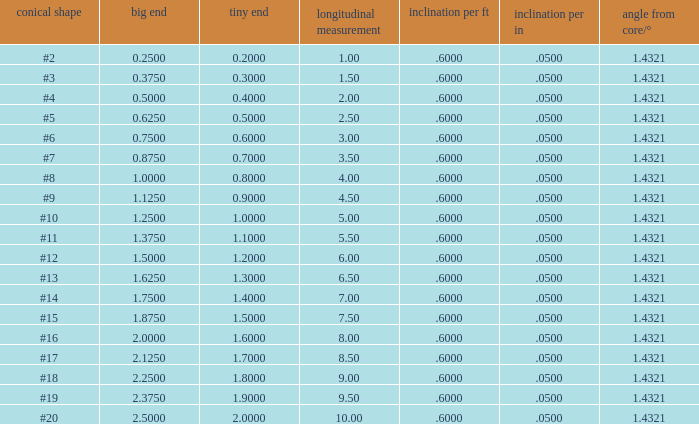Which Length has a Taper of #15, and a Large end larger than 1.875? None. Write the full table. {'header': ['conical shape', 'big end', 'tiny end', 'longitudinal measurement', 'inclination per ft', 'inclination per in', 'angle from core/°'], 'rows': [['#2', '0.2500', '0.2000', '1.00', '.6000', '.0500', '1.4321'], ['#3', '0.3750', '0.3000', '1.50', '.6000', '.0500', '1.4321'], ['#4', '0.5000', '0.4000', '2.00', '.6000', '.0500', '1.4321'], ['#5', '0.6250', '0.5000', '2.50', '.6000', '.0500', '1.4321'], ['#6', '0.7500', '0.6000', '3.00', '.6000', '.0500', '1.4321'], ['#7', '0.8750', '0.7000', '3.50', '.6000', '.0500', '1.4321'], ['#8', '1.0000', '0.8000', '4.00', '.6000', '.0500', '1.4321'], ['#9', '1.1250', '0.9000', '4.50', '.6000', '.0500', '1.4321'], ['#10', '1.2500', '1.0000', '5.00', '.6000', '.0500', '1.4321'], ['#11', '1.3750', '1.1000', '5.50', '.6000', '.0500', '1.4321'], ['#12', '1.5000', '1.2000', '6.00', '.6000', '.0500', '1.4321'], ['#13', '1.6250', '1.3000', '6.50', '.6000', '.0500', '1.4321'], ['#14', '1.7500', '1.4000', '7.00', '.6000', '.0500', '1.4321'], ['#15', '1.8750', '1.5000', '7.50', '.6000', '.0500', '1.4321'], ['#16', '2.0000', '1.6000', '8.00', '.6000', '.0500', '1.4321'], ['#17', '2.1250', '1.7000', '8.50', '.6000', '.0500', '1.4321'], ['#18', '2.2500', '1.8000', '9.00', '.6000', '.0500', '1.4321'], ['#19', '2.3750', '1.9000', '9.50', '.6000', '.0500', '1.4321'], ['#20', '2.5000', '2.0000', '10.00', '.6000', '.0500', '1.4321']]} 